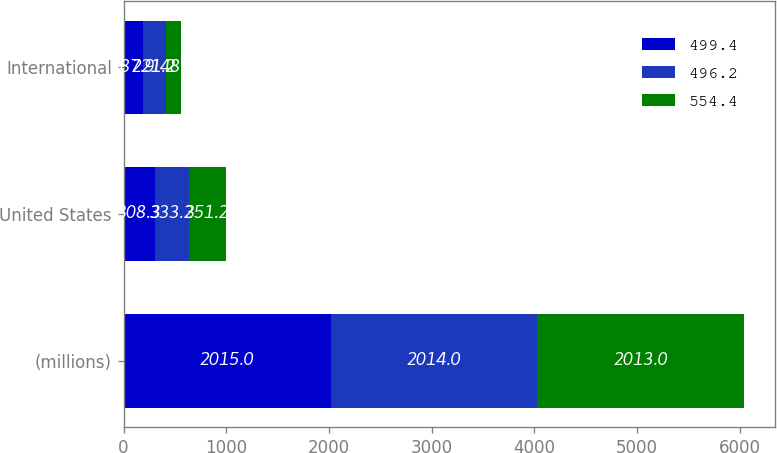Convert chart. <chart><loc_0><loc_0><loc_500><loc_500><stacked_bar_chart><ecel><fcel>(millions)<fcel>United States<fcel>International<nl><fcel>499.4<fcel>2015<fcel>308.3<fcel>187.9<nl><fcel>496.2<fcel>2014<fcel>333.2<fcel>221.2<nl><fcel>554.4<fcel>2013<fcel>351.2<fcel>148.2<nl></chart> 